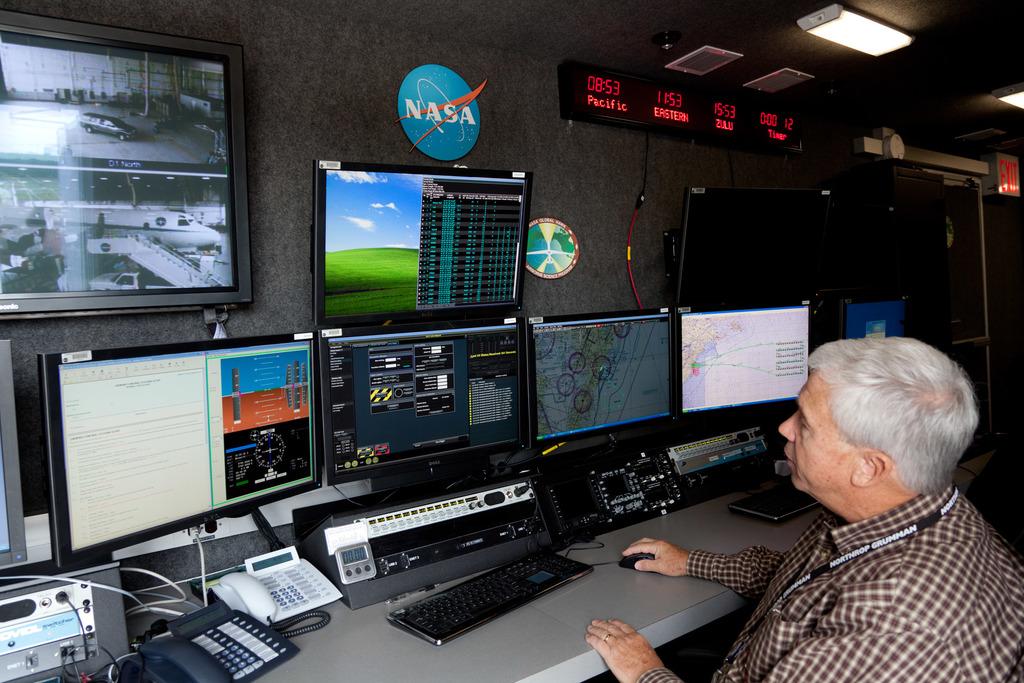What company is the man working at?
Give a very brief answer. Nasa. What time zone is mentioned on the far left?
Offer a terse response. Pacific. 